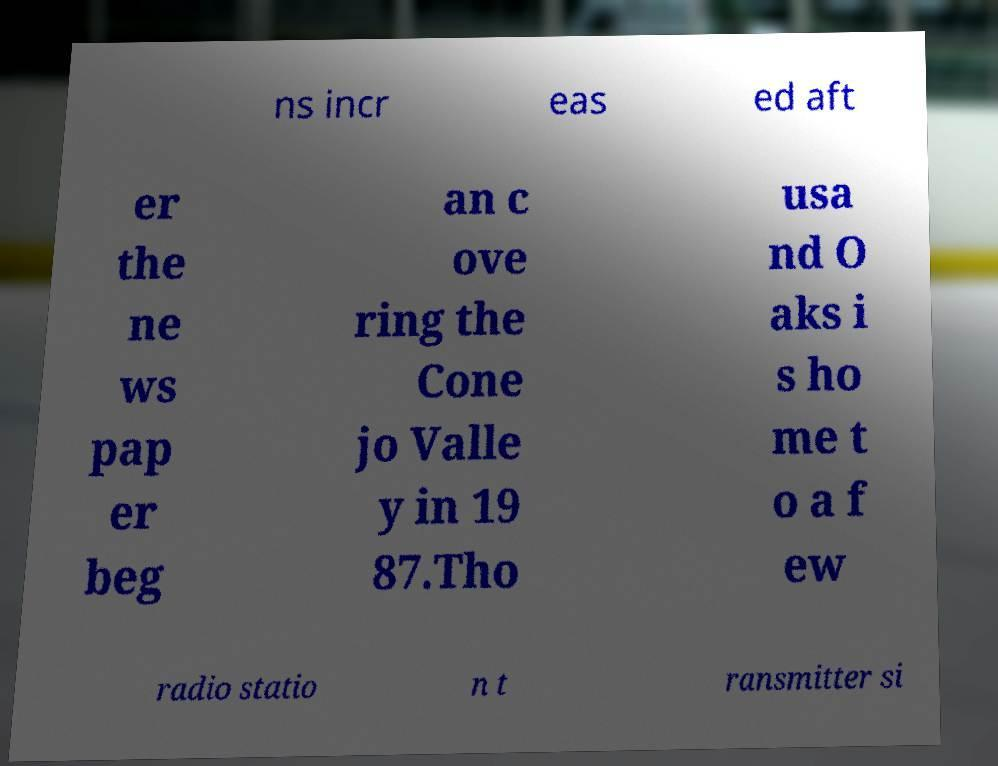Could you extract and type out the text from this image? ns incr eas ed aft er the ne ws pap er beg an c ove ring the Cone jo Valle y in 19 87.Tho usa nd O aks i s ho me t o a f ew radio statio n t ransmitter si 